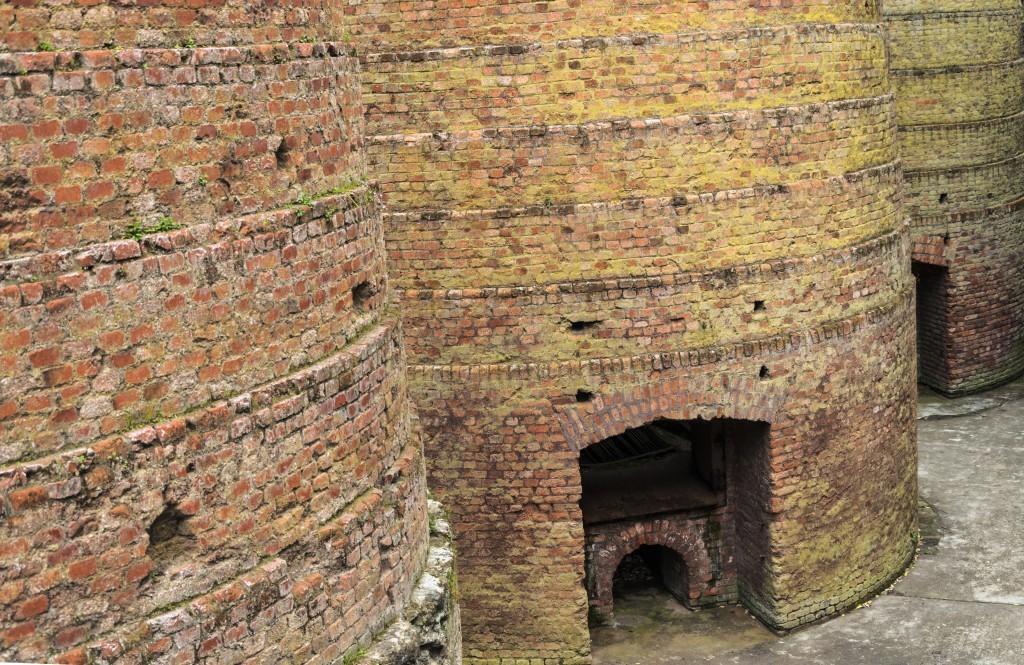Please provide a concise description of this image. The picture consist of brick wall. In the center, at the bottom there is a way. 